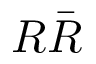Convert formula to latex. <formula><loc_0><loc_0><loc_500><loc_500>R \bar { R }</formula> 